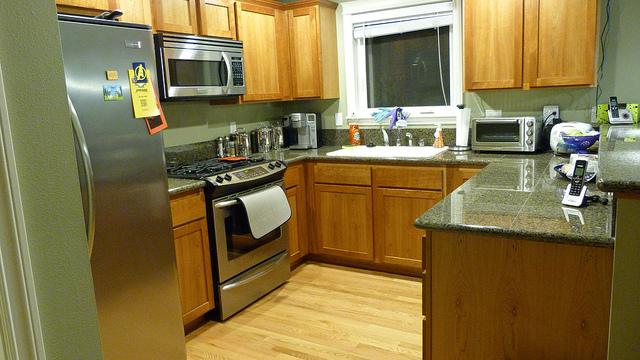What is the floor made of?
Concise answer only. Wood. What room is this?
Answer briefly. Kitchen. What color are the appliances?
Be succinct. Silver. 